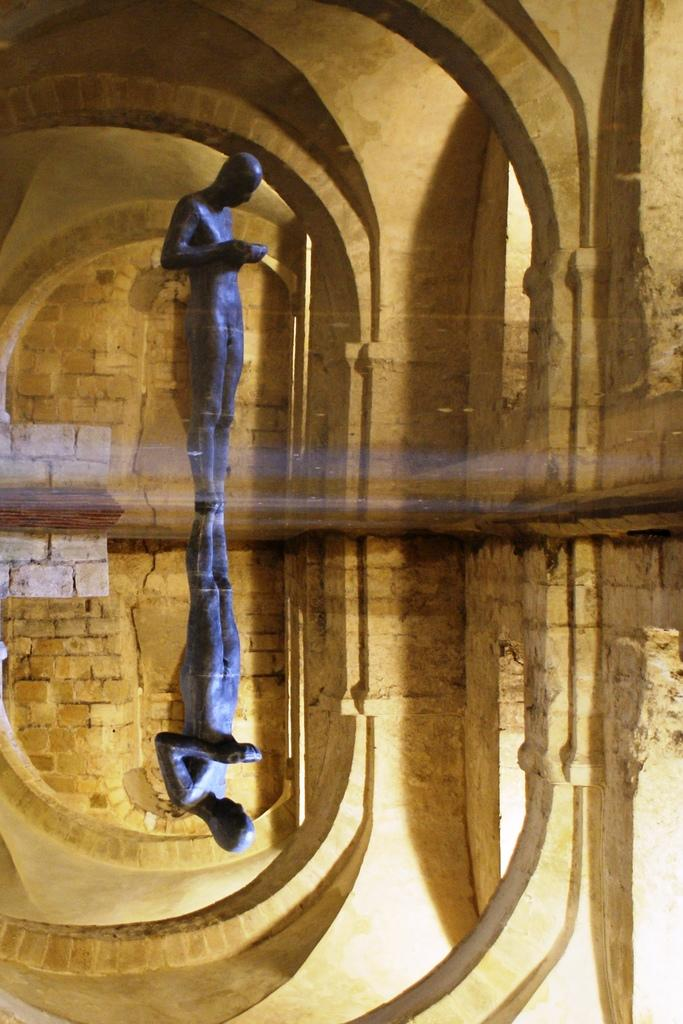What is the main subject in the image? There is a statue in the image. Can you describe any editing or alterations in the image? The image appears to be edited. What can be seen in the background of the image? There is a wall with pillars in the background of the image. What type of setting is suggested by the background? The background setting resembles an old fort. What type of tin can be seen in the image? There is no tin present in the image. Is there a trail leading to the statue in the image? The image does not show a trail leading to the statue. 